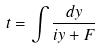Convert formula to latex. <formula><loc_0><loc_0><loc_500><loc_500>t = \int \frac { d y } { i y + F }</formula> 